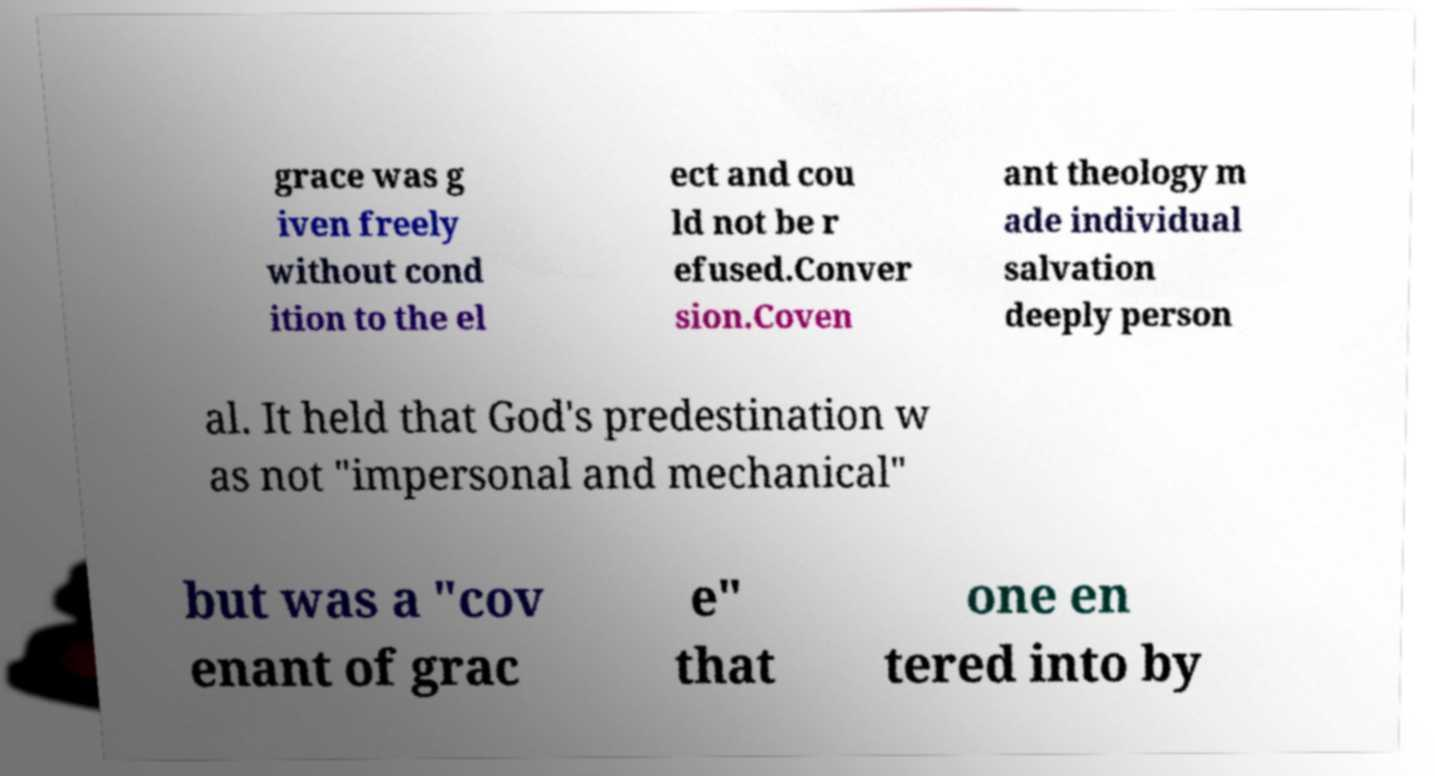For documentation purposes, I need the text within this image transcribed. Could you provide that? grace was g iven freely without cond ition to the el ect and cou ld not be r efused.Conver sion.Coven ant theology m ade individual salvation deeply person al. It held that God's predestination w as not "impersonal and mechanical" but was a "cov enant of grac e" that one en tered into by 